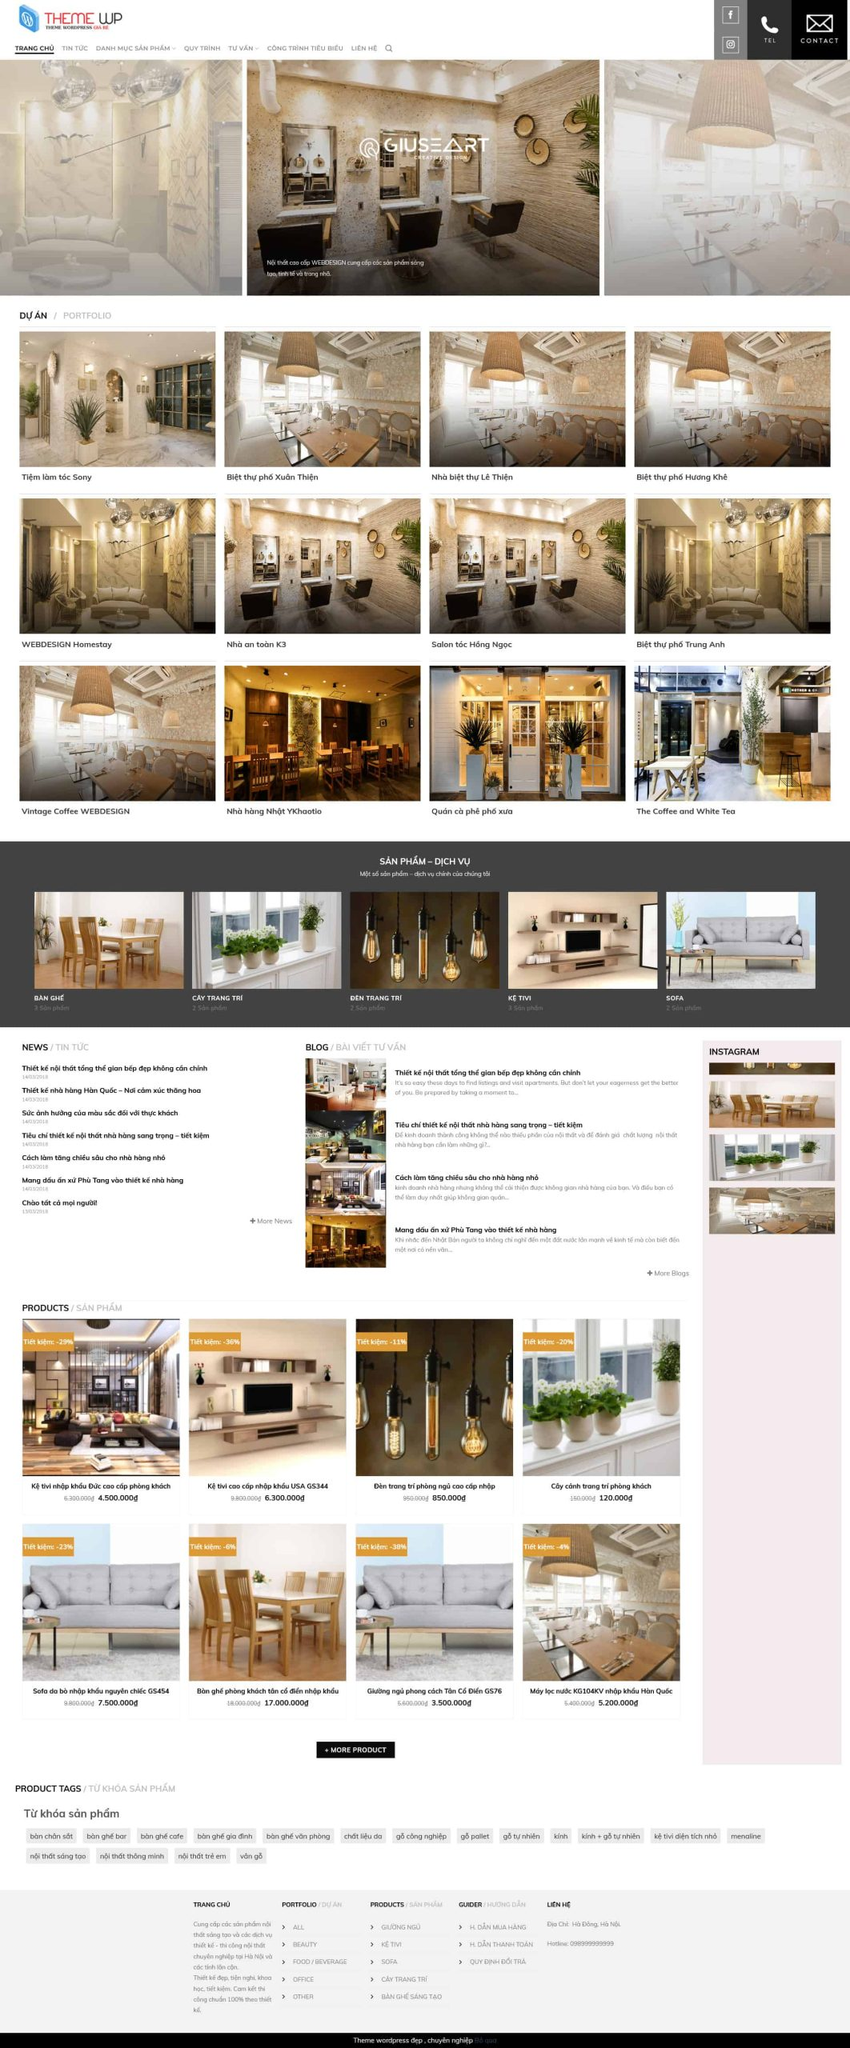Liệt kê 5 ngành nghề, lĩnh vực phù hợp với website này, phân cách các màu sắc bằng dấu phẩy. Chỉ trả về kết quả, phân cách bằng dấy phẩy
 Nội thất, Kiến trúc, Trang trí, Thiết kế, Xây dựng 